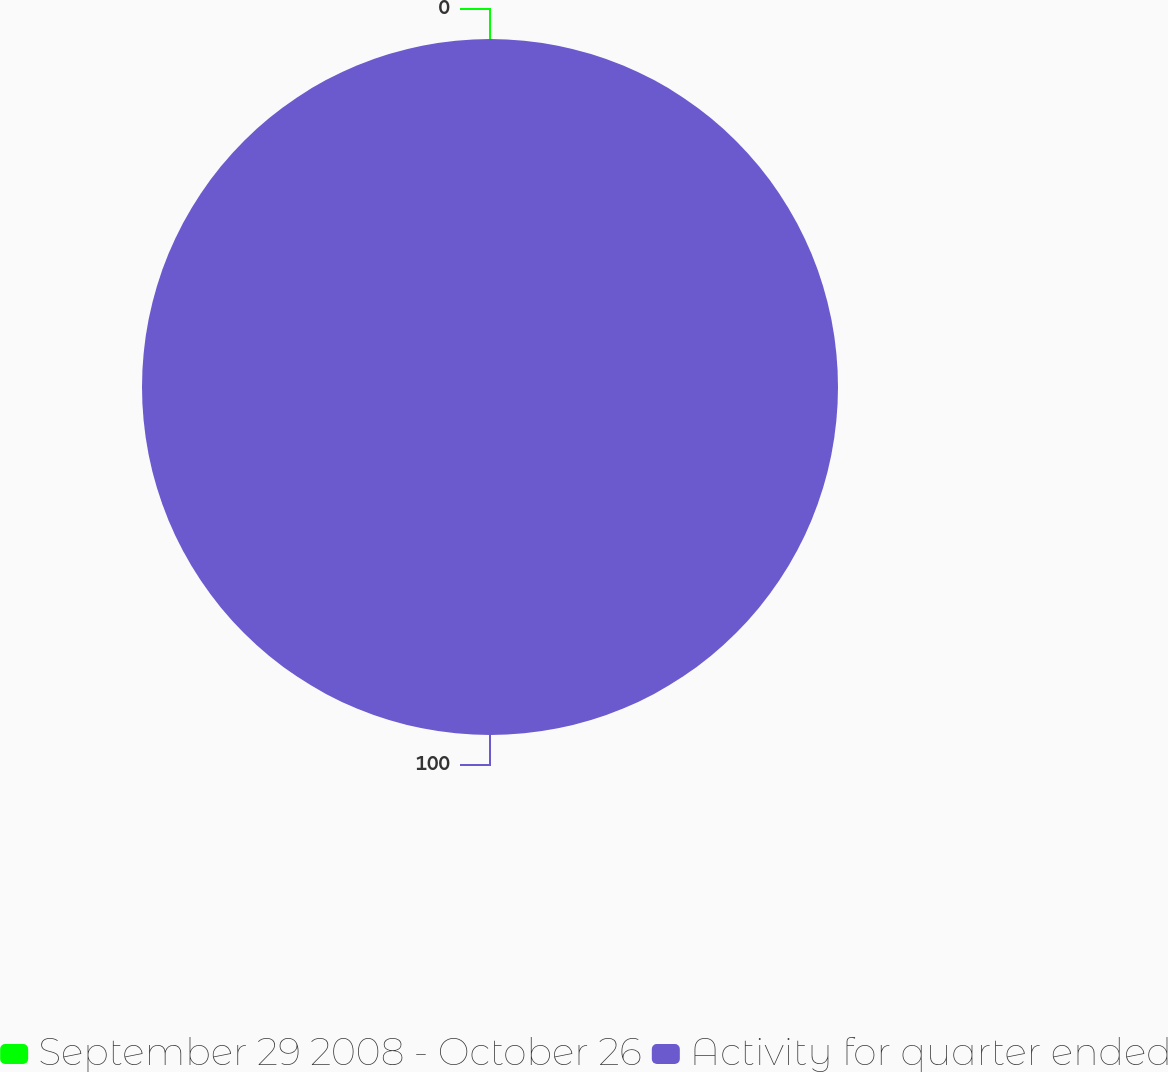Convert chart to OTSL. <chart><loc_0><loc_0><loc_500><loc_500><pie_chart><fcel>September 29 2008 - October 26<fcel>Activity for quarter ended<nl><fcel>0.0%<fcel>100.0%<nl></chart> 